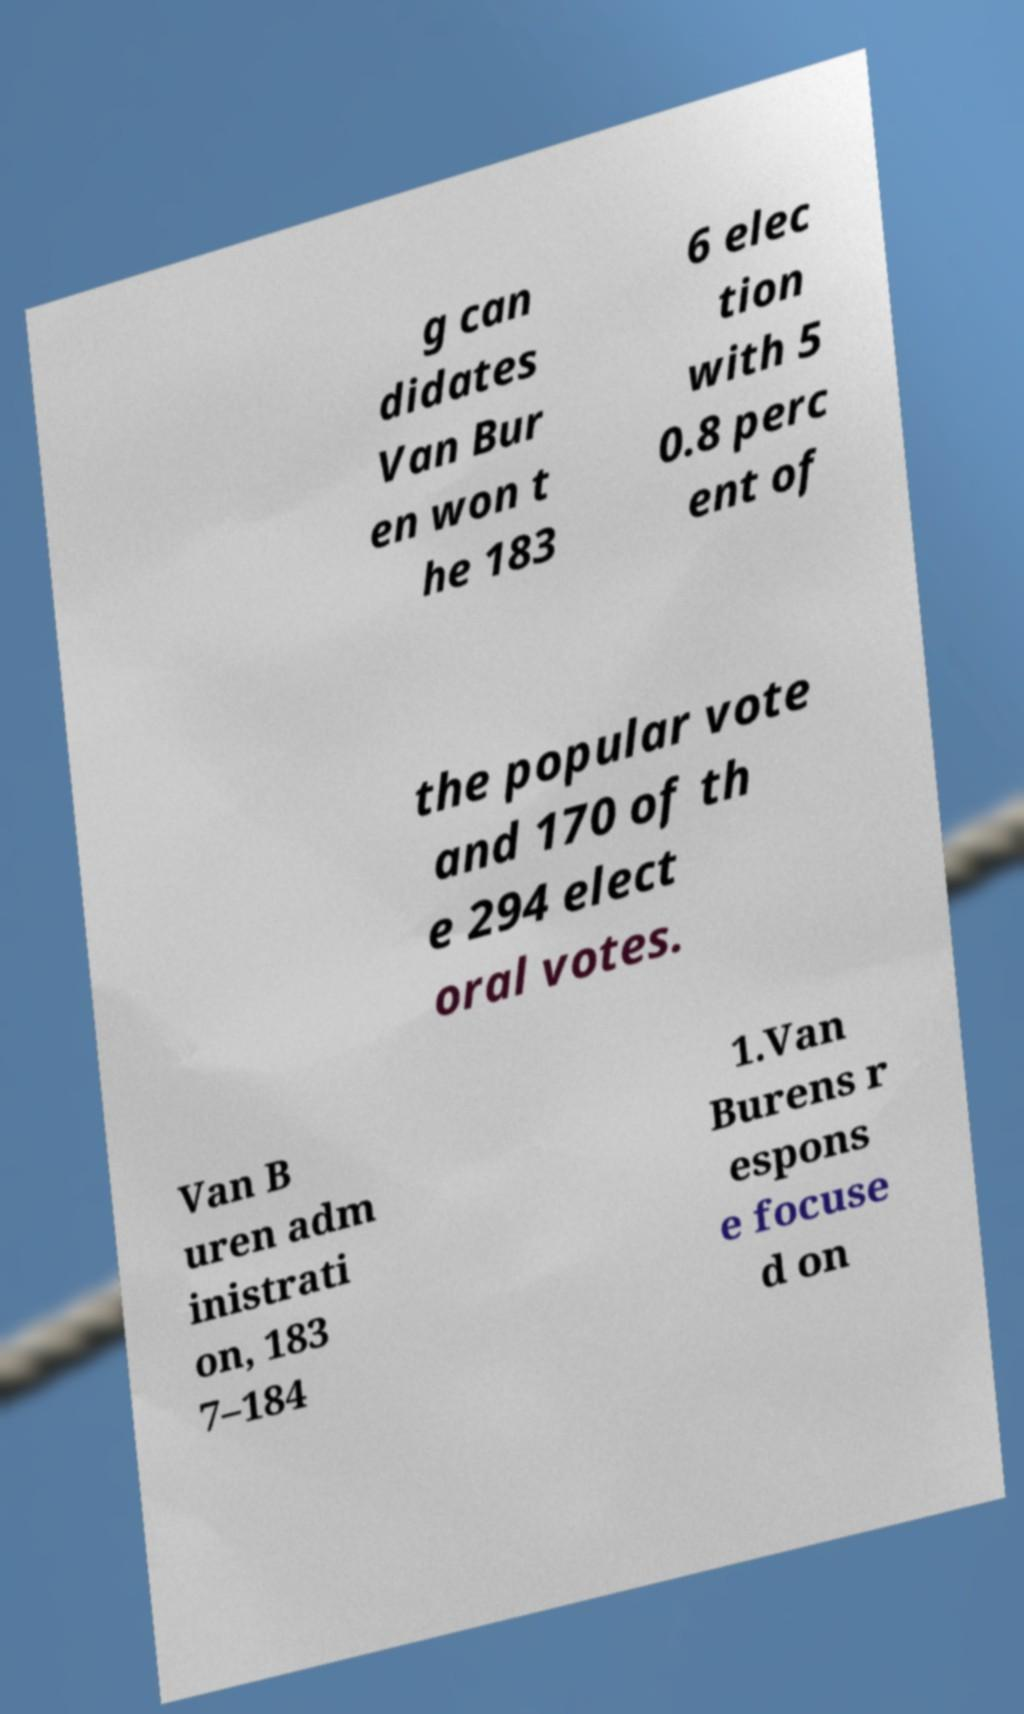Please read and relay the text visible in this image. What does it say? g can didates Van Bur en won t he 183 6 elec tion with 5 0.8 perc ent of the popular vote and 170 of th e 294 elect oral votes. Van B uren adm inistrati on, 183 7–184 1.Van Burens r espons e focuse d on 